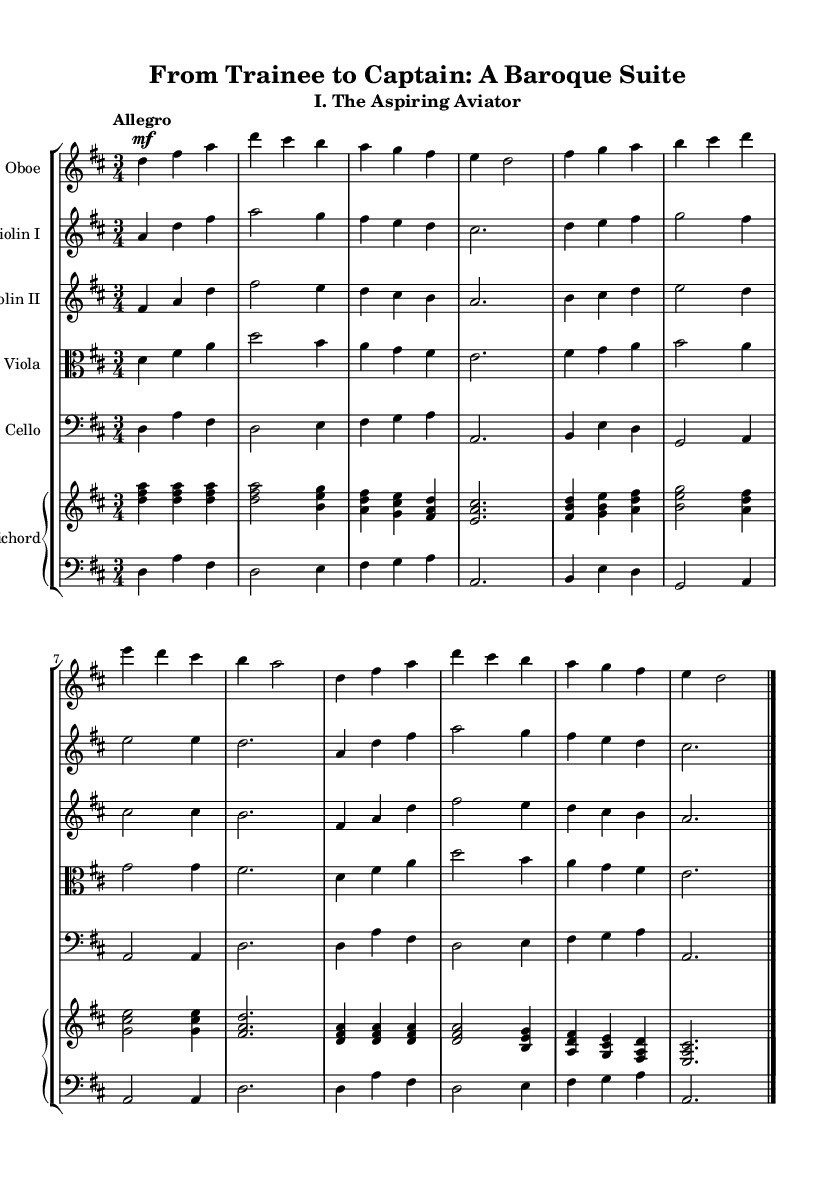What is the key signature of this music? The key signature is indicated at the beginning of the staff, showing two sharps. This indicates that the key is D major.
Answer: D major What is the time signature of this music? The time signature is found at the beginning of the piece, represented as "3/4", which means there are three beats per measure, and the quarter note gets one beat.
Answer: 3/4 What is the tempo marking for this piece? The tempo marking, written as "Allegro" at the beginning, indicates a fast and lively pace for the performance.
Answer: Allegro How many measures are in the first section of the music? Counting the vertical lines in the music, which represent the bar lines, there are 8 measures in the first section of the music before the end bar line.
Answer: 8 Which instrument plays the highest notes in this piece? By examining the treble clef portions of the score, the oboe consistently occupies the highest pitch range compared to the other instruments.
Answer: Oboe What form of music is represented in this piece? This piece follows the structure of a suite, which is characterized by a series of dances or movements often in a related key. Evidence of movement styles can be inferred from the characteristic tempo and articulation markings throughout.
Answer: Suite 